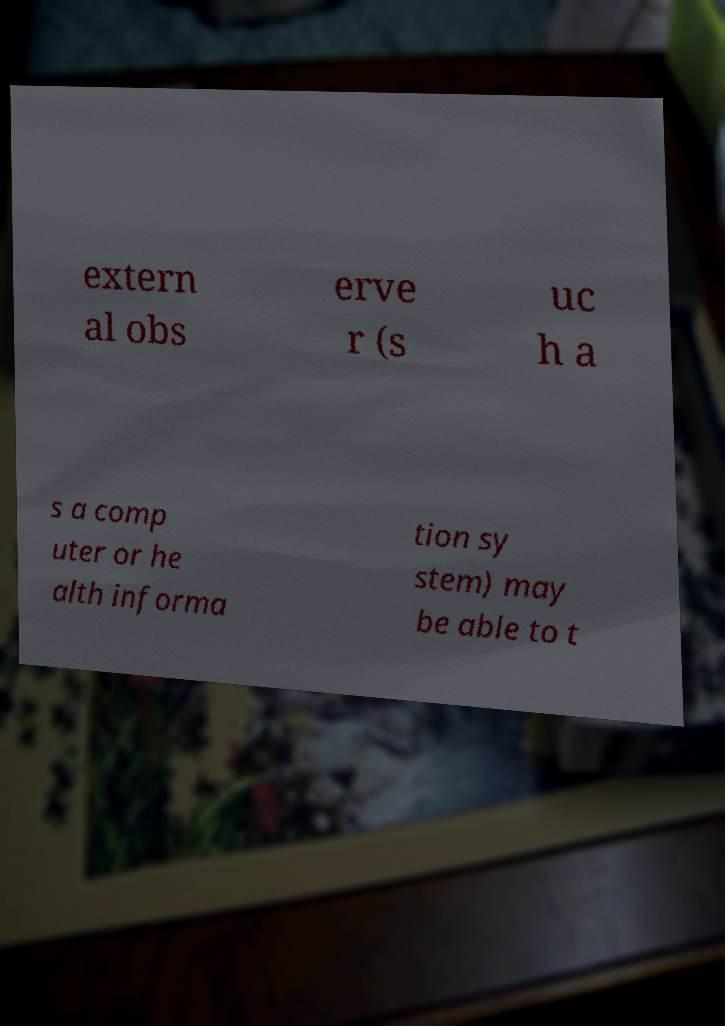Could you assist in decoding the text presented in this image and type it out clearly? extern al obs erve r (s uc h a s a comp uter or he alth informa tion sy stem) may be able to t 